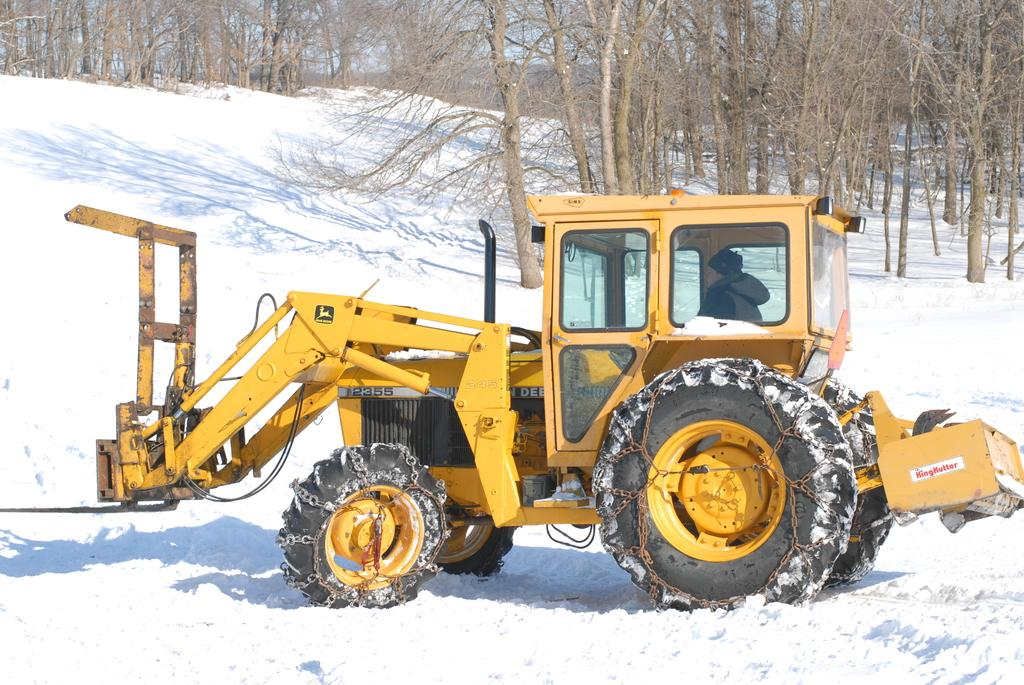What is happening in the image? There is a person in the image, and they are riding a vehicle. What is the terrain like in the image? The vehicle is on snow. What can be seen in the background of the image? There are trees and the sky visible at the top of the image. What type of crime is being committed in the image? There is no crime being committed in the image; it features a person riding a vehicle on snow. What kind of building is visible in the image? There is no building visible in the image; it only shows a person riding a vehicle on snow, trees, and the sky. 